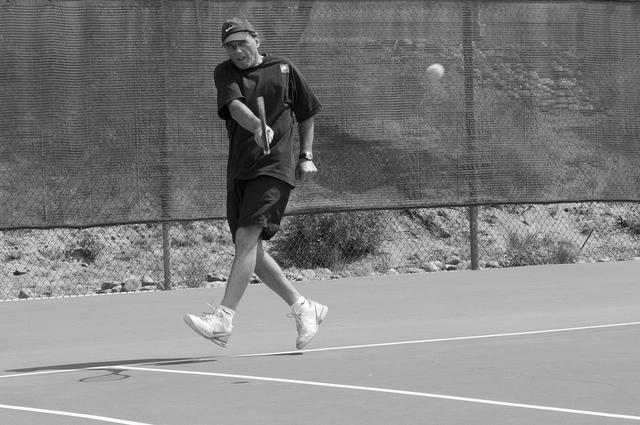How many people are visible?
Give a very brief answer. 1. 